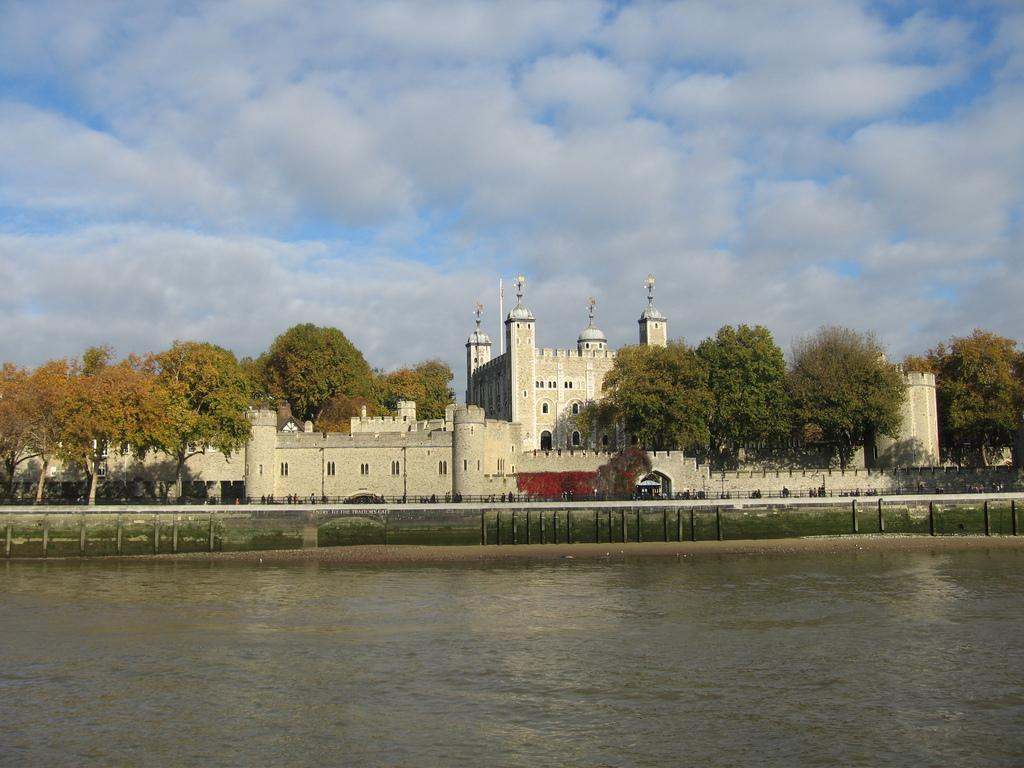What is the main feature of the image? The main feature of the image is water. What can be seen on the other side of the water? There are trees and buildings on the other side of the water. What is visible in the sky at the top of the image? There are clouds in the sky at the top of the image. What type of butter is being used to create the wind in the image? There is no butter or wind present in the image; it features water, trees, buildings, and clouds. 